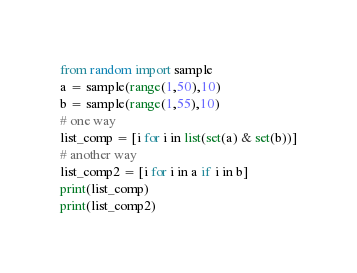<code> <loc_0><loc_0><loc_500><loc_500><_Python_>from random import sample
a = sample(range(1,50),10)
b = sample(range(1,55),10)
# one way
list_comp = [i for i in list(set(a) & set(b))]
# another way
list_comp2 = [i for i in a if i in b]
print(list_comp)
print(list_comp2)</code> 